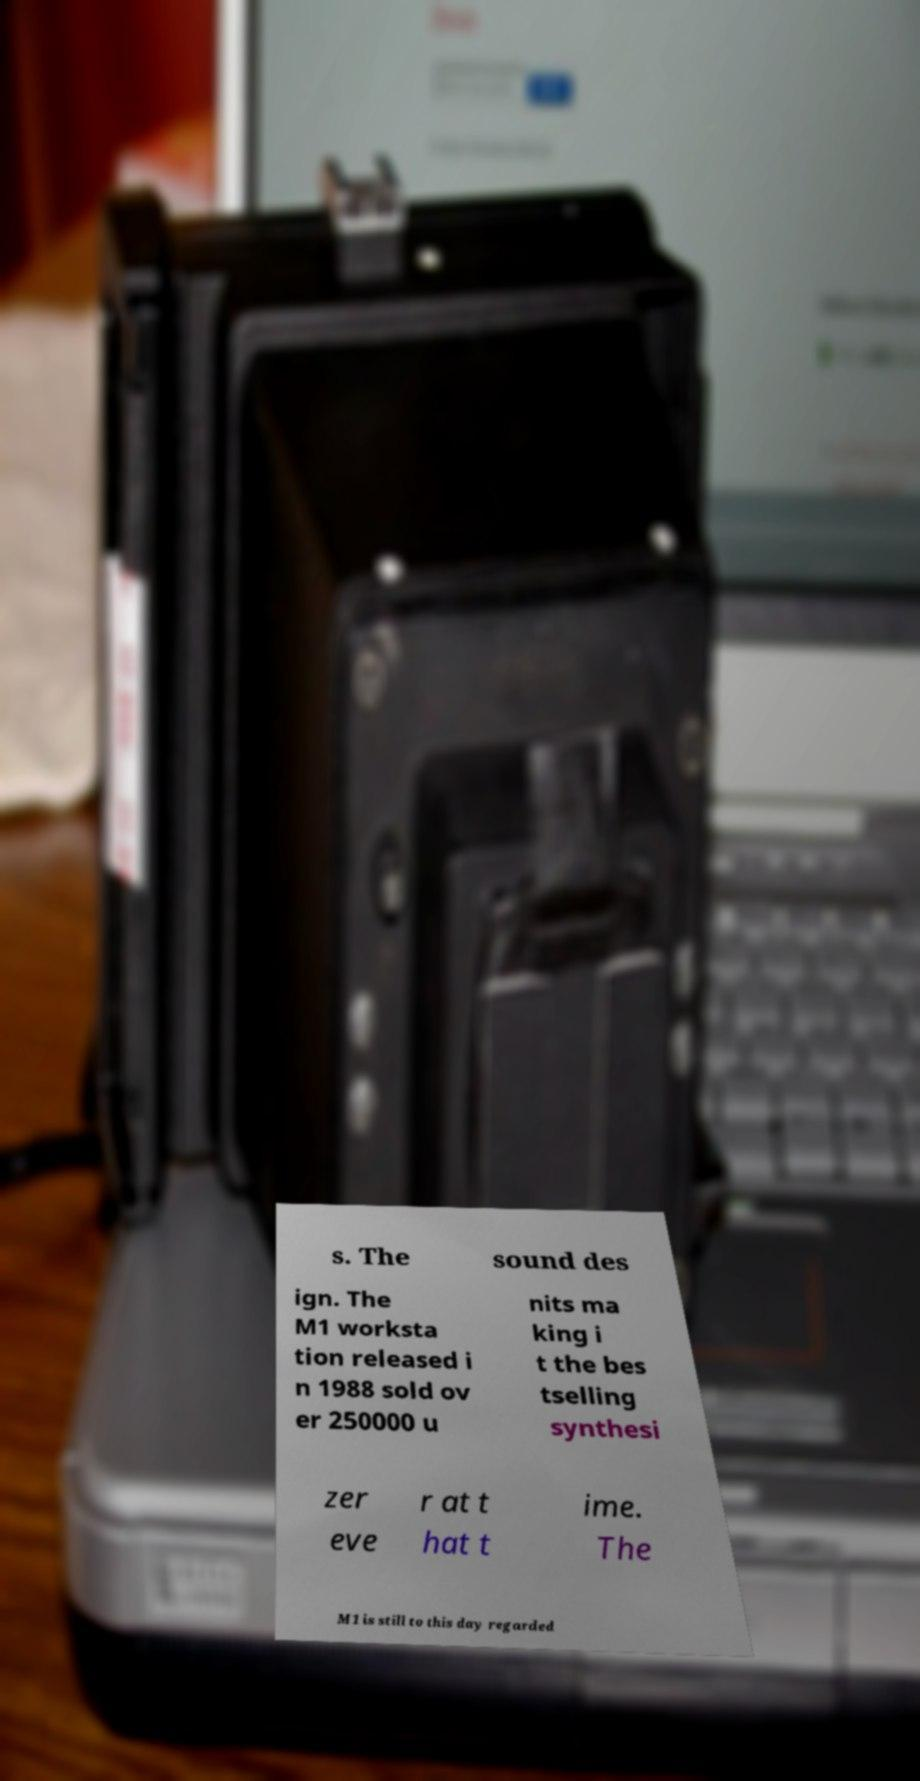What messages or text are displayed in this image? I need them in a readable, typed format. s. The sound des ign. The M1 worksta tion released i n 1988 sold ov er 250000 u nits ma king i t the bes tselling synthesi zer eve r at t hat t ime. The M1 is still to this day regarded 